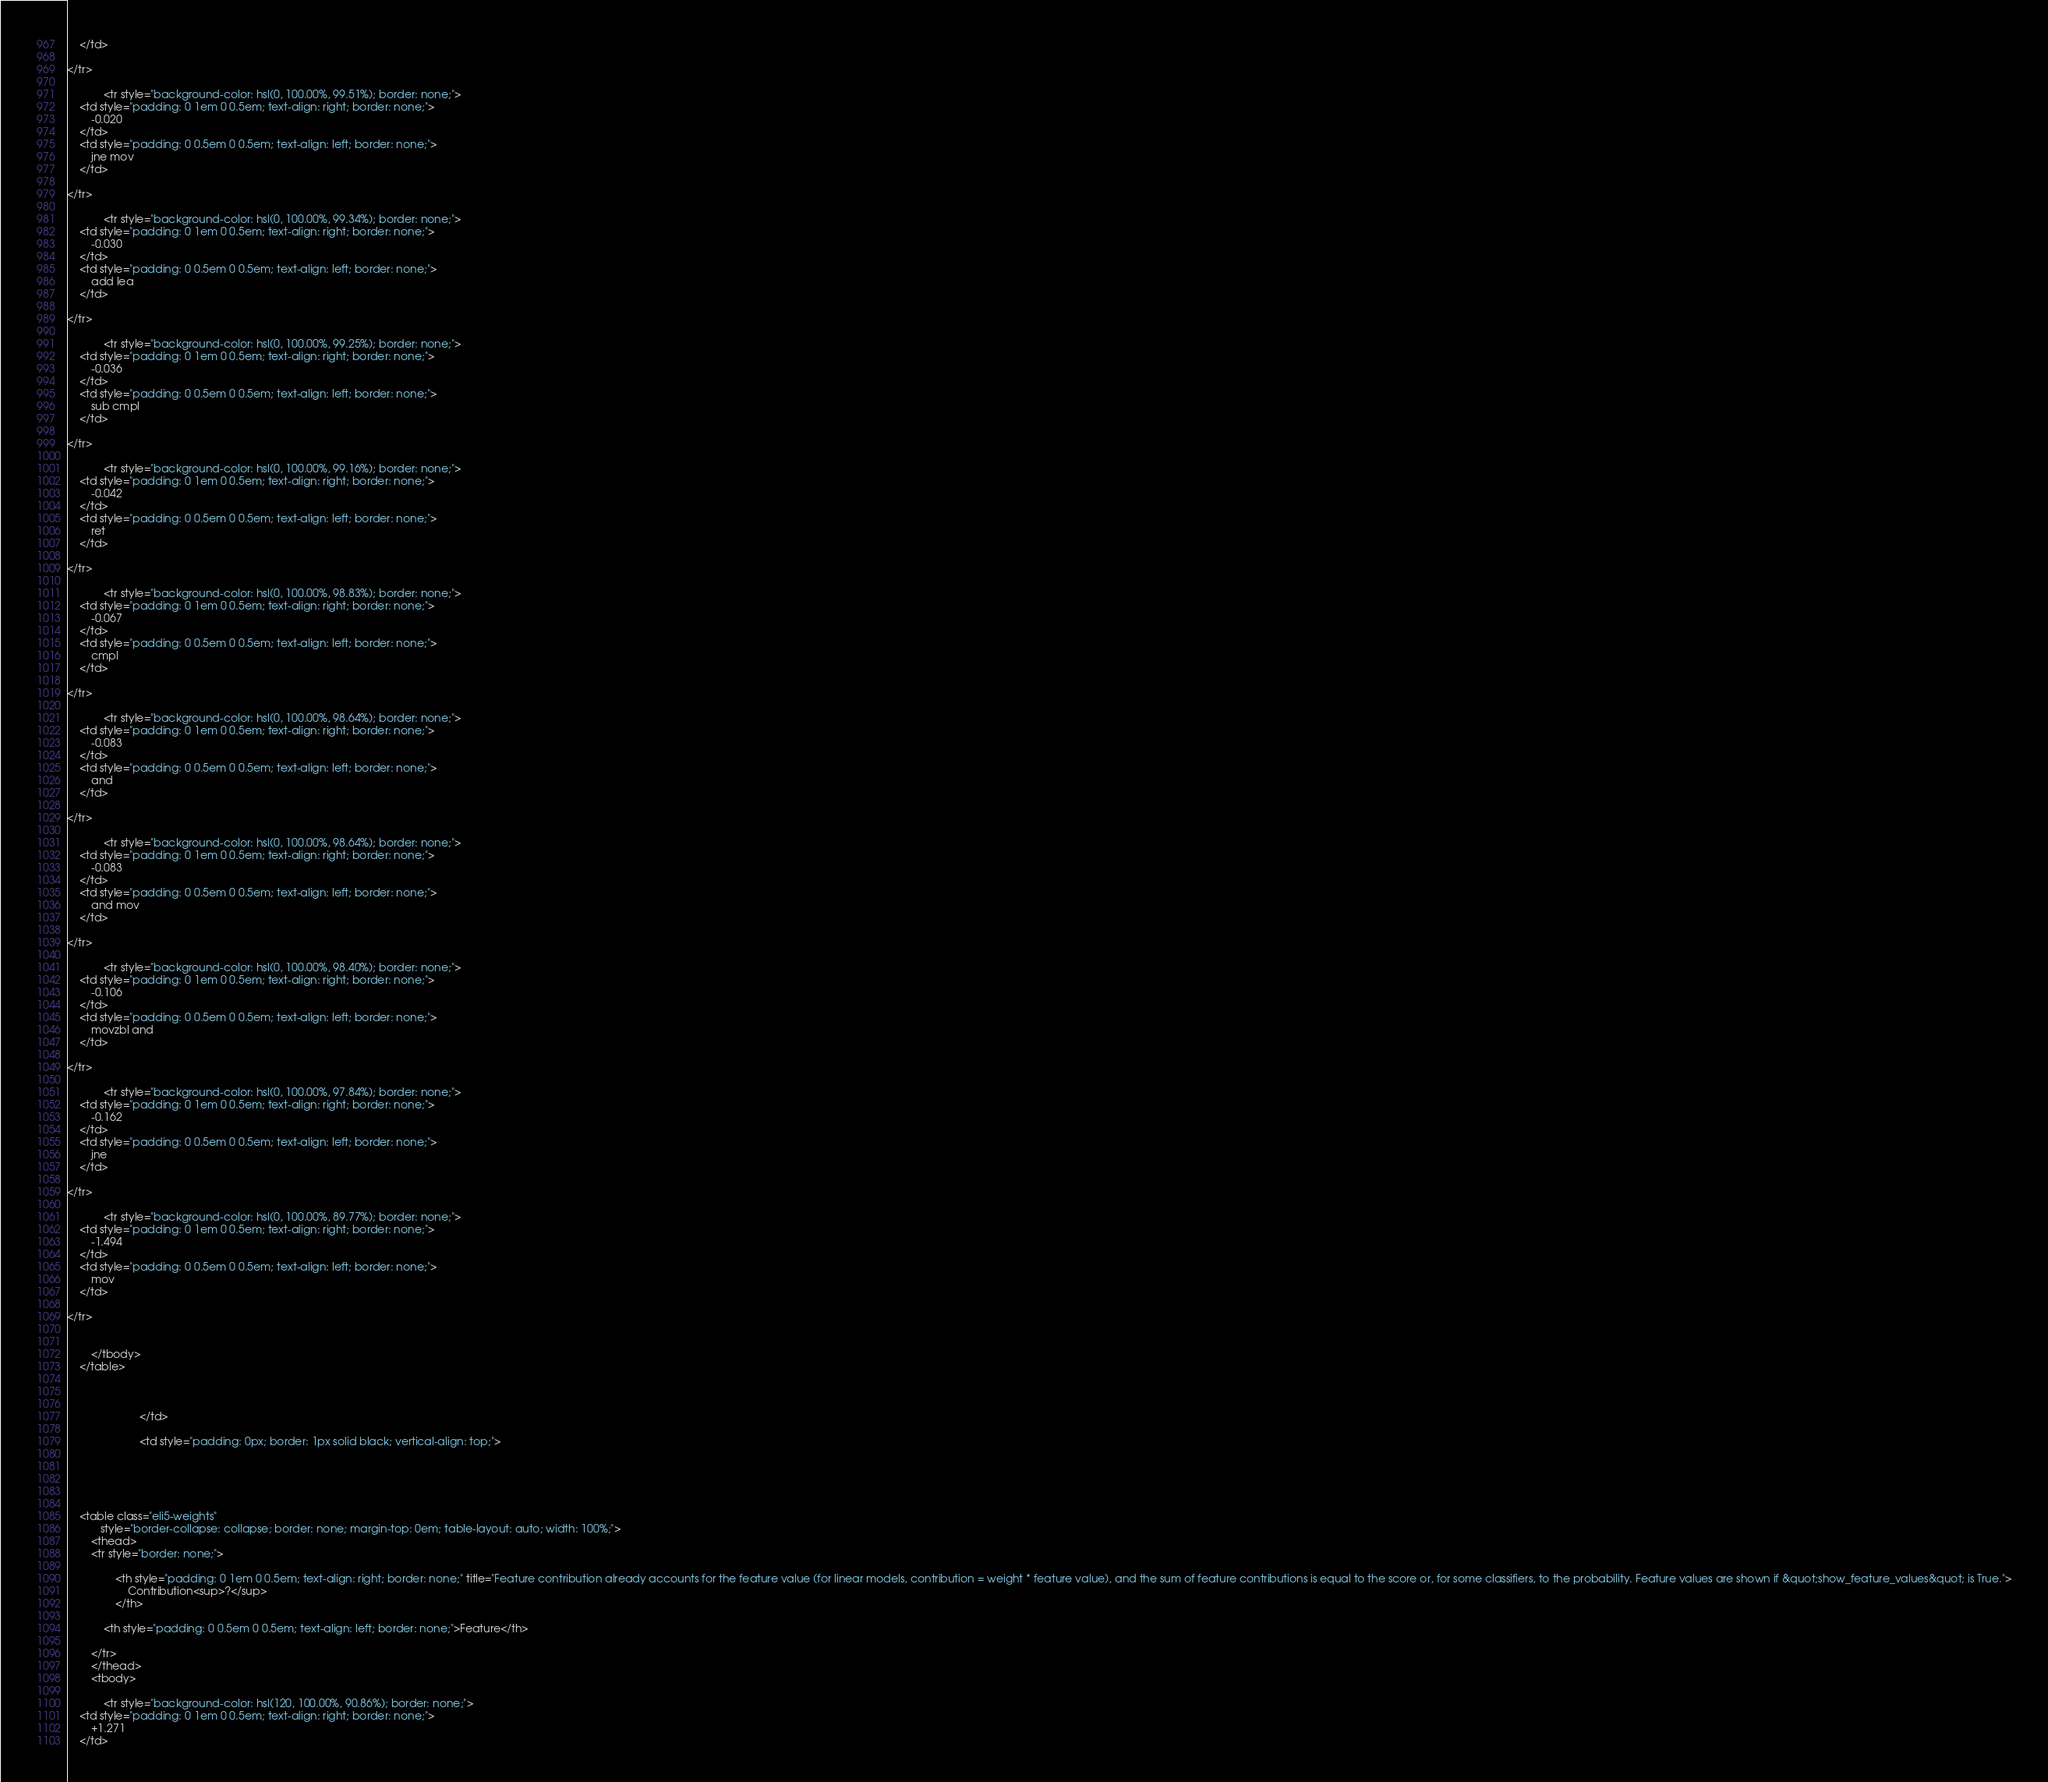<code> <loc_0><loc_0><loc_500><loc_500><_HTML_>    </td>
    
</tr>
        
            <tr style="background-color: hsl(0, 100.00%, 99.51%); border: none;">
    <td style="padding: 0 1em 0 0.5em; text-align: right; border: none;">
        -0.020
    </td>
    <td style="padding: 0 0.5em 0 0.5em; text-align: left; border: none;">
        jne mov
    </td>
    
</tr>
        
            <tr style="background-color: hsl(0, 100.00%, 99.34%); border: none;">
    <td style="padding: 0 1em 0 0.5em; text-align: right; border: none;">
        -0.030
    </td>
    <td style="padding: 0 0.5em 0 0.5em; text-align: left; border: none;">
        add lea
    </td>
    
</tr>
        
            <tr style="background-color: hsl(0, 100.00%, 99.25%); border: none;">
    <td style="padding: 0 1em 0 0.5em; text-align: right; border: none;">
        -0.036
    </td>
    <td style="padding: 0 0.5em 0 0.5em; text-align: left; border: none;">
        sub cmpl
    </td>
    
</tr>
        
            <tr style="background-color: hsl(0, 100.00%, 99.16%); border: none;">
    <td style="padding: 0 1em 0 0.5em; text-align: right; border: none;">
        -0.042
    </td>
    <td style="padding: 0 0.5em 0 0.5em; text-align: left; border: none;">
        ret
    </td>
    
</tr>
        
            <tr style="background-color: hsl(0, 100.00%, 98.83%); border: none;">
    <td style="padding: 0 1em 0 0.5em; text-align: right; border: none;">
        -0.067
    </td>
    <td style="padding: 0 0.5em 0 0.5em; text-align: left; border: none;">
        cmpl
    </td>
    
</tr>
        
            <tr style="background-color: hsl(0, 100.00%, 98.64%); border: none;">
    <td style="padding: 0 1em 0 0.5em; text-align: right; border: none;">
        -0.083
    </td>
    <td style="padding: 0 0.5em 0 0.5em; text-align: left; border: none;">
        and
    </td>
    
</tr>
        
            <tr style="background-color: hsl(0, 100.00%, 98.64%); border: none;">
    <td style="padding: 0 1em 0 0.5em; text-align: right; border: none;">
        -0.083
    </td>
    <td style="padding: 0 0.5em 0 0.5em; text-align: left; border: none;">
        and mov
    </td>
    
</tr>
        
            <tr style="background-color: hsl(0, 100.00%, 98.40%); border: none;">
    <td style="padding: 0 1em 0 0.5em; text-align: right; border: none;">
        -0.106
    </td>
    <td style="padding: 0 0.5em 0 0.5em; text-align: left; border: none;">
        movzbl and
    </td>
    
</tr>
        
            <tr style="background-color: hsl(0, 100.00%, 97.84%); border: none;">
    <td style="padding: 0 1em 0 0.5em; text-align: right; border: none;">
        -0.162
    </td>
    <td style="padding: 0 0.5em 0 0.5em; text-align: left; border: none;">
        jne
    </td>
    
</tr>
        
            <tr style="background-color: hsl(0, 100.00%, 89.77%); border: none;">
    <td style="padding: 0 1em 0 0.5em; text-align: right; border: none;">
        -1.494
    </td>
    <td style="padding: 0 0.5em 0 0.5em; text-align: left; border: none;">
        mov
    </td>
    
</tr>
        

        </tbody>
    </table>

                                
                            
                        </td>
                    
                        <td style="padding: 0px; border: 1px solid black; vertical-align: top;">
                            
                                
                                    
                                    
    
    <table class="eli5-weights"
           style="border-collapse: collapse; border: none; margin-top: 0em; table-layout: auto; width: 100%;">
        <thead>
        <tr style="border: none;">
            
                <th style="padding: 0 1em 0 0.5em; text-align: right; border: none;" title="Feature contribution already accounts for the feature value (for linear models, contribution = weight * feature value), and the sum of feature contributions is equal to the score or, for some classifiers, to the probability. Feature values are shown if &quot;show_feature_values&quot; is True.">
                    Contribution<sup>?</sup>
                </th>
            
            <th style="padding: 0 0.5em 0 0.5em; text-align: left; border: none;">Feature</th>
            
        </tr>
        </thead>
        <tbody>
        
            <tr style="background-color: hsl(120, 100.00%, 90.86%); border: none;">
    <td style="padding: 0 1em 0 0.5em; text-align: right; border: none;">
        +1.271
    </td></code> 